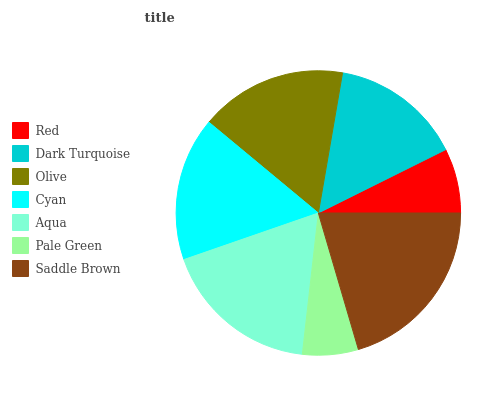Is Pale Green the minimum?
Answer yes or no. Yes. Is Saddle Brown the maximum?
Answer yes or no. Yes. Is Dark Turquoise the minimum?
Answer yes or no. No. Is Dark Turquoise the maximum?
Answer yes or no. No. Is Dark Turquoise greater than Red?
Answer yes or no. Yes. Is Red less than Dark Turquoise?
Answer yes or no. Yes. Is Red greater than Dark Turquoise?
Answer yes or no. No. Is Dark Turquoise less than Red?
Answer yes or no. No. Is Cyan the high median?
Answer yes or no. Yes. Is Cyan the low median?
Answer yes or no. Yes. Is Dark Turquoise the high median?
Answer yes or no. No. Is Aqua the low median?
Answer yes or no. No. 